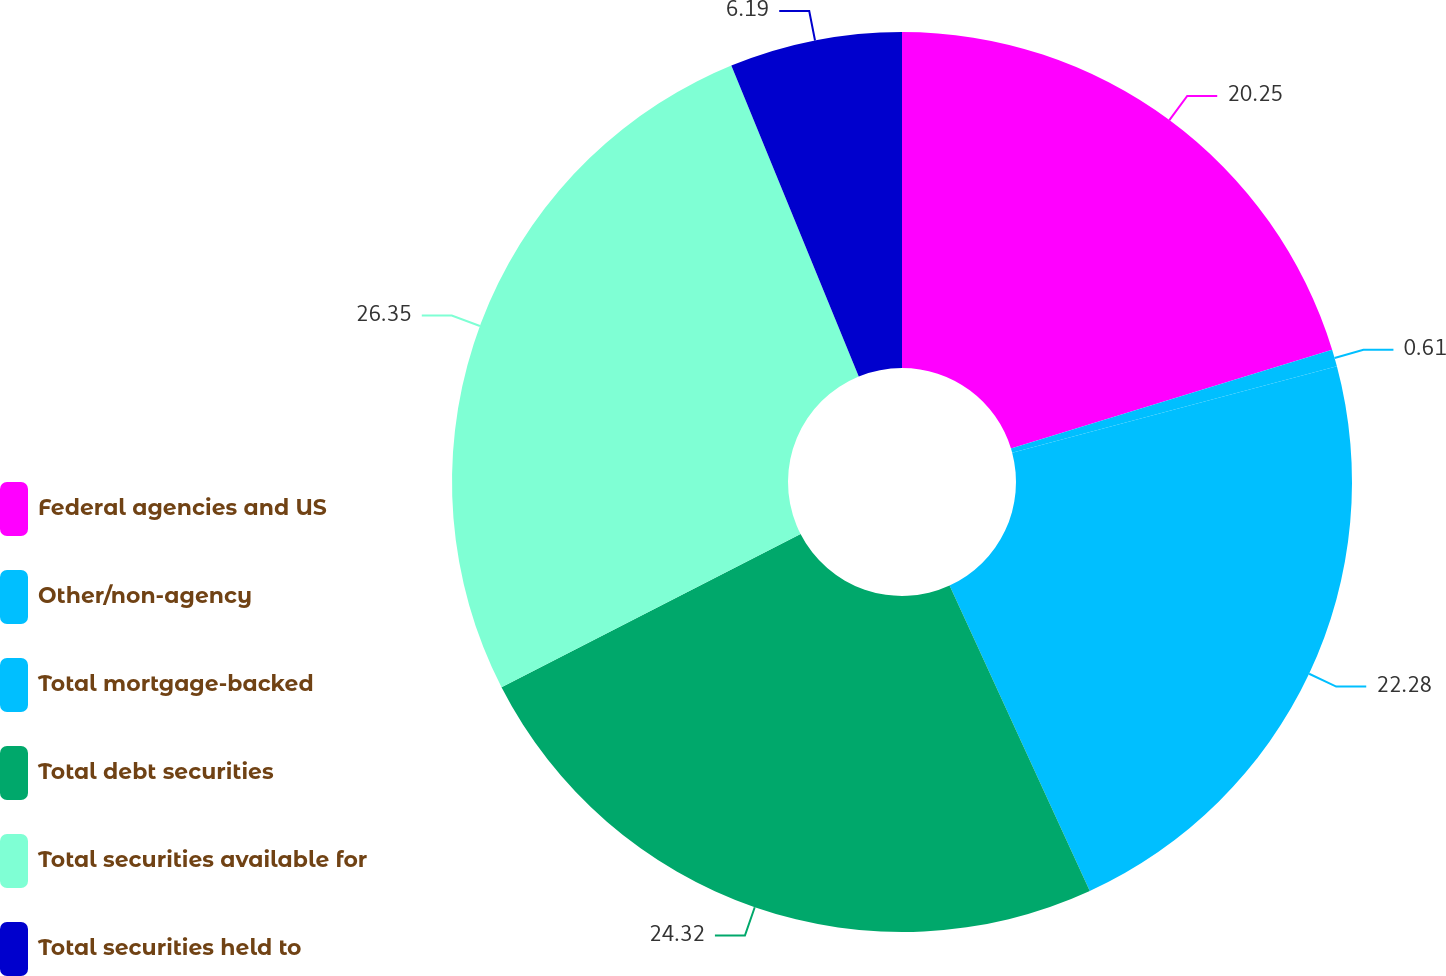Convert chart. <chart><loc_0><loc_0><loc_500><loc_500><pie_chart><fcel>Federal agencies and US<fcel>Other/non-agency<fcel>Total mortgage-backed<fcel>Total debt securities<fcel>Total securities available for<fcel>Total securities held to<nl><fcel>20.25%<fcel>0.61%<fcel>22.28%<fcel>24.31%<fcel>26.34%<fcel>6.19%<nl></chart> 